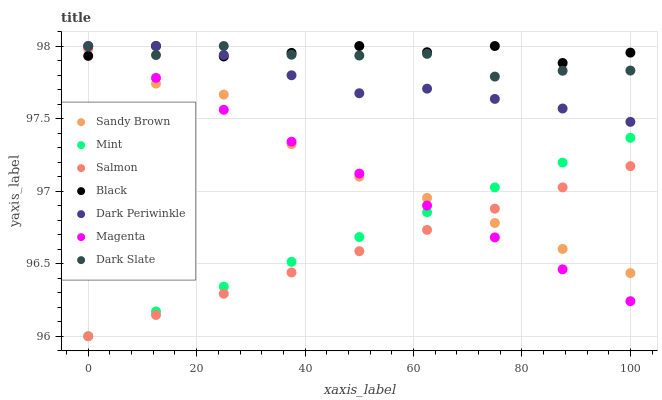Does Salmon have the minimum area under the curve?
Answer yes or no. Yes. Does Black have the maximum area under the curve?
Answer yes or no. Yes. Does Dark Slate have the minimum area under the curve?
Answer yes or no. No. Does Dark Slate have the maximum area under the curve?
Answer yes or no. No. Is Mint the smoothest?
Answer yes or no. Yes. Is Black the roughest?
Answer yes or no. Yes. Is Salmon the smoothest?
Answer yes or no. No. Is Salmon the roughest?
Answer yes or no. No. Does Salmon have the lowest value?
Answer yes or no. Yes. Does Dark Slate have the lowest value?
Answer yes or no. No. Does Dark Periwinkle have the highest value?
Answer yes or no. Yes. Does Salmon have the highest value?
Answer yes or no. No. Is Salmon less than Dark Slate?
Answer yes or no. Yes. Is Dark Periwinkle greater than Salmon?
Answer yes or no. Yes. Does Dark Periwinkle intersect Magenta?
Answer yes or no. Yes. Is Dark Periwinkle less than Magenta?
Answer yes or no. No. Is Dark Periwinkle greater than Magenta?
Answer yes or no. No. Does Salmon intersect Dark Slate?
Answer yes or no. No. 